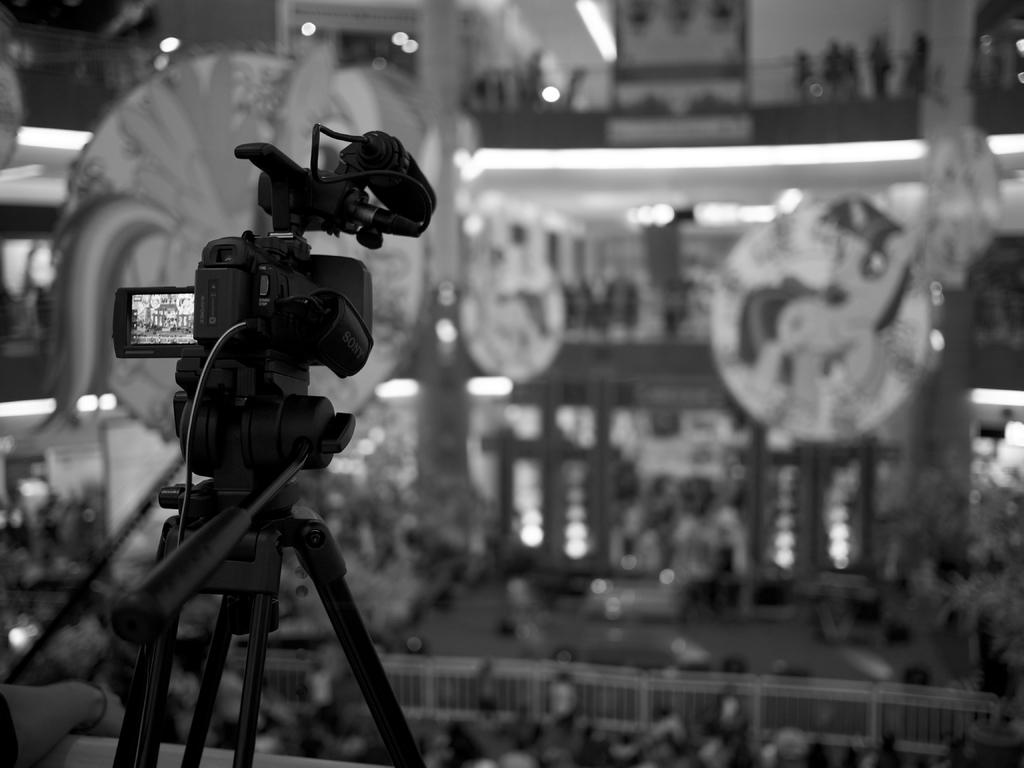What is the color scheme of the image? The image is black and white. What can be seen in the image related to filming or recording? There is a video camera on a stand in the image. What is the appearance of the background in the image? The background of the image is blurred. What other objects can be seen in the image? There are railings and lights visible in the image. Can you tell me how many rabbits are hopping around in the image? There are no rabbits present in the image; it features a video camera on a stand, a blurred background, railings, and lights. What type of credit card is shown in the image? There is no credit card present in the image. 